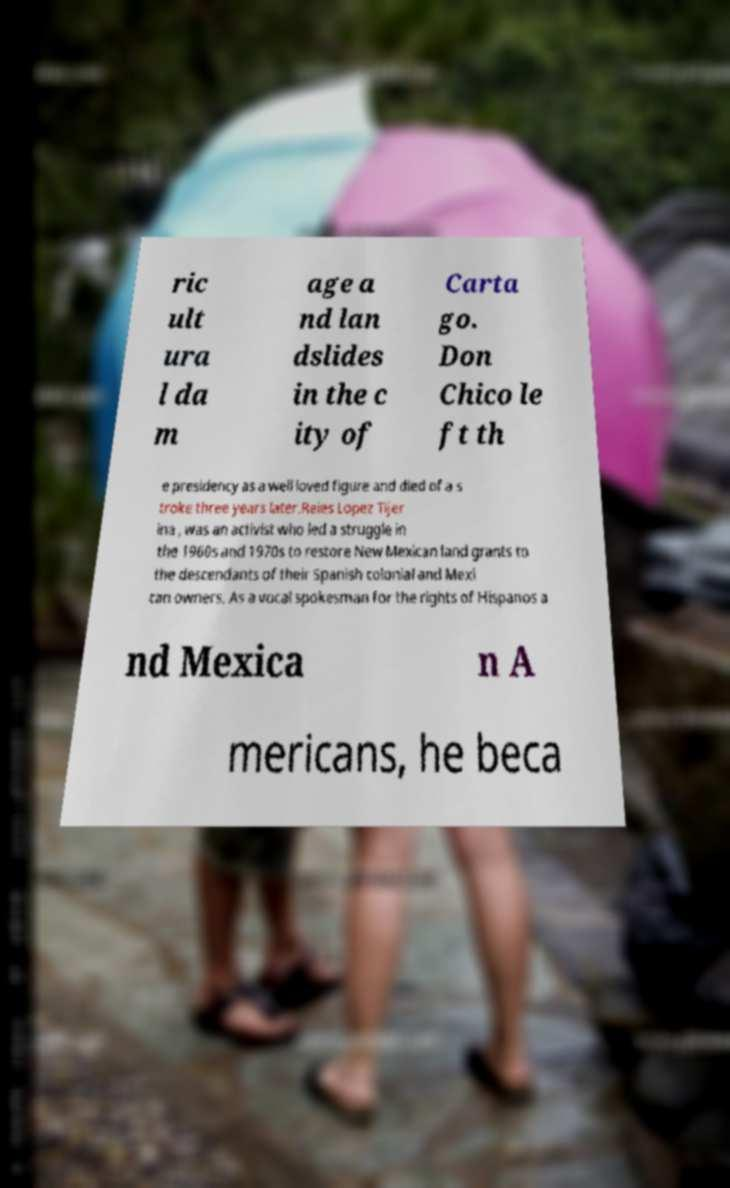Could you assist in decoding the text presented in this image and type it out clearly? ric ult ura l da m age a nd lan dslides in the c ity of Carta go. Don Chico le ft th e presidency as a well loved figure and died of a s troke three years later.Reies Lopez Tijer ina , was an activist who led a struggle in the 1960s and 1970s to restore New Mexican land grants to the descendants of their Spanish colonial and Mexi can owners. As a vocal spokesman for the rights of Hispanos a nd Mexica n A mericans, he beca 